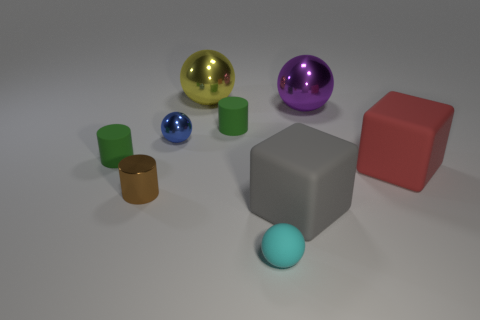Subtract all balls. How many objects are left? 5 Add 2 cyan spheres. How many cyan spheres exist? 3 Subtract 1 red cubes. How many objects are left? 8 Subtract all big blue blocks. Subtract all gray cubes. How many objects are left? 8 Add 5 red things. How many red things are left? 6 